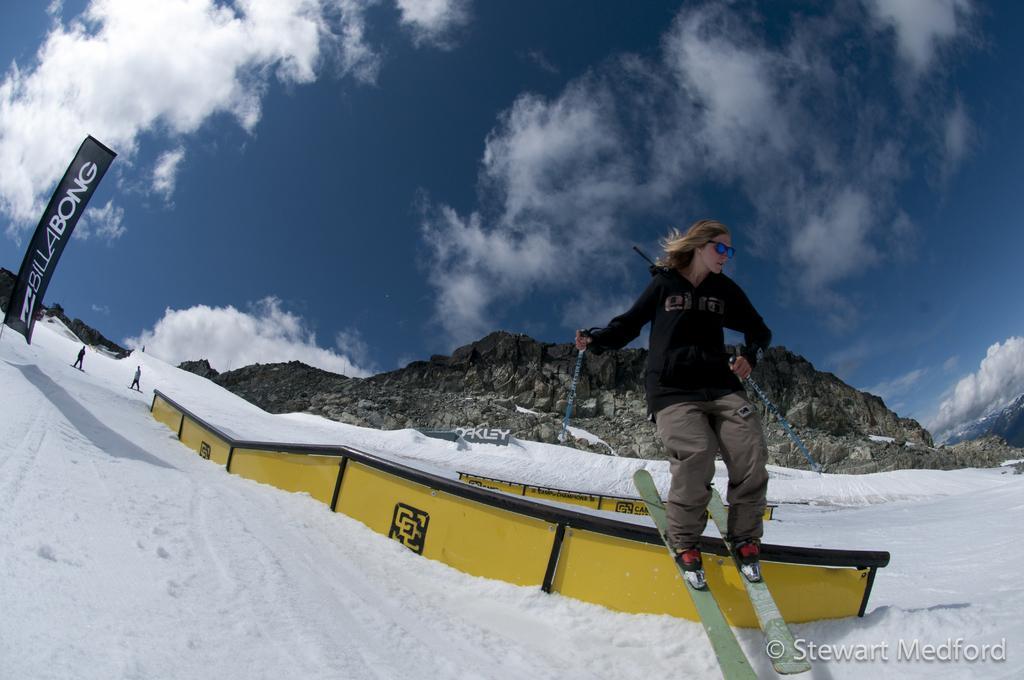How would you summarize this image in a sentence or two? In this image, we can see a person above the snow with ski boards and holding sticks with her hands. There is a banner on the left side of the image. There is a hill in the middle of the image. There are clouds in the sky. There is a metal wall at the bottom of the image. 